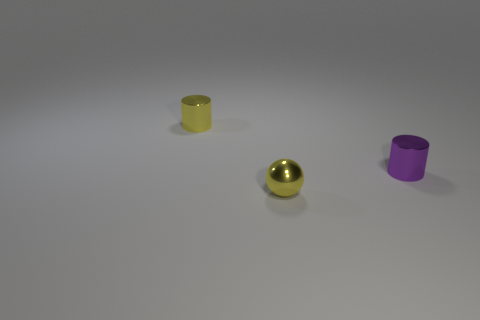Add 2 small yellow metal balls. How many objects exist? 5 Subtract all balls. How many objects are left? 2 Add 1 purple objects. How many purple objects are left? 2 Add 1 tiny purple metallic cylinders. How many tiny purple metallic cylinders exist? 2 Subtract 0 green balls. How many objects are left? 3 Subtract all tiny metallic things. Subtract all big cyan matte blocks. How many objects are left? 0 